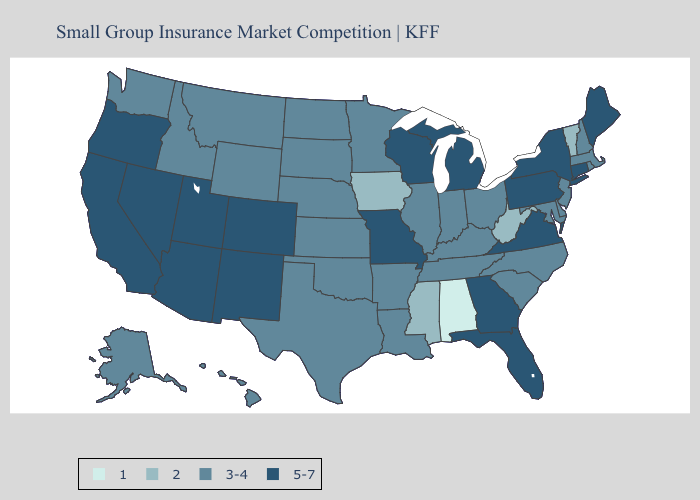Does South Carolina have the highest value in the USA?
Be succinct. No. Does Arizona have a lower value than New Jersey?
Short answer required. No. Name the states that have a value in the range 3-4?
Keep it brief. Alaska, Arkansas, Delaware, Hawaii, Idaho, Illinois, Indiana, Kansas, Kentucky, Louisiana, Maryland, Massachusetts, Minnesota, Montana, Nebraska, New Hampshire, New Jersey, North Carolina, North Dakota, Ohio, Oklahoma, Rhode Island, South Carolina, South Dakota, Tennessee, Texas, Washington, Wyoming. What is the highest value in states that border Washington?
Be succinct. 5-7. What is the lowest value in the MidWest?
Quick response, please. 2. Does Delaware have the highest value in the USA?
Keep it brief. No. Name the states that have a value in the range 1?
Write a very short answer. Alabama. Which states have the lowest value in the USA?
Concise answer only. Alabama. Which states have the lowest value in the USA?
Quick response, please. Alabama. Among the states that border Minnesota , does Iowa have the lowest value?
Be succinct. Yes. Does the first symbol in the legend represent the smallest category?
Be succinct. Yes. Does Kansas have a higher value than Iowa?
Quick response, please. Yes. What is the lowest value in the USA?
Be succinct. 1. What is the highest value in the Northeast ?
Concise answer only. 5-7. What is the value of Kansas?
Give a very brief answer. 3-4. 